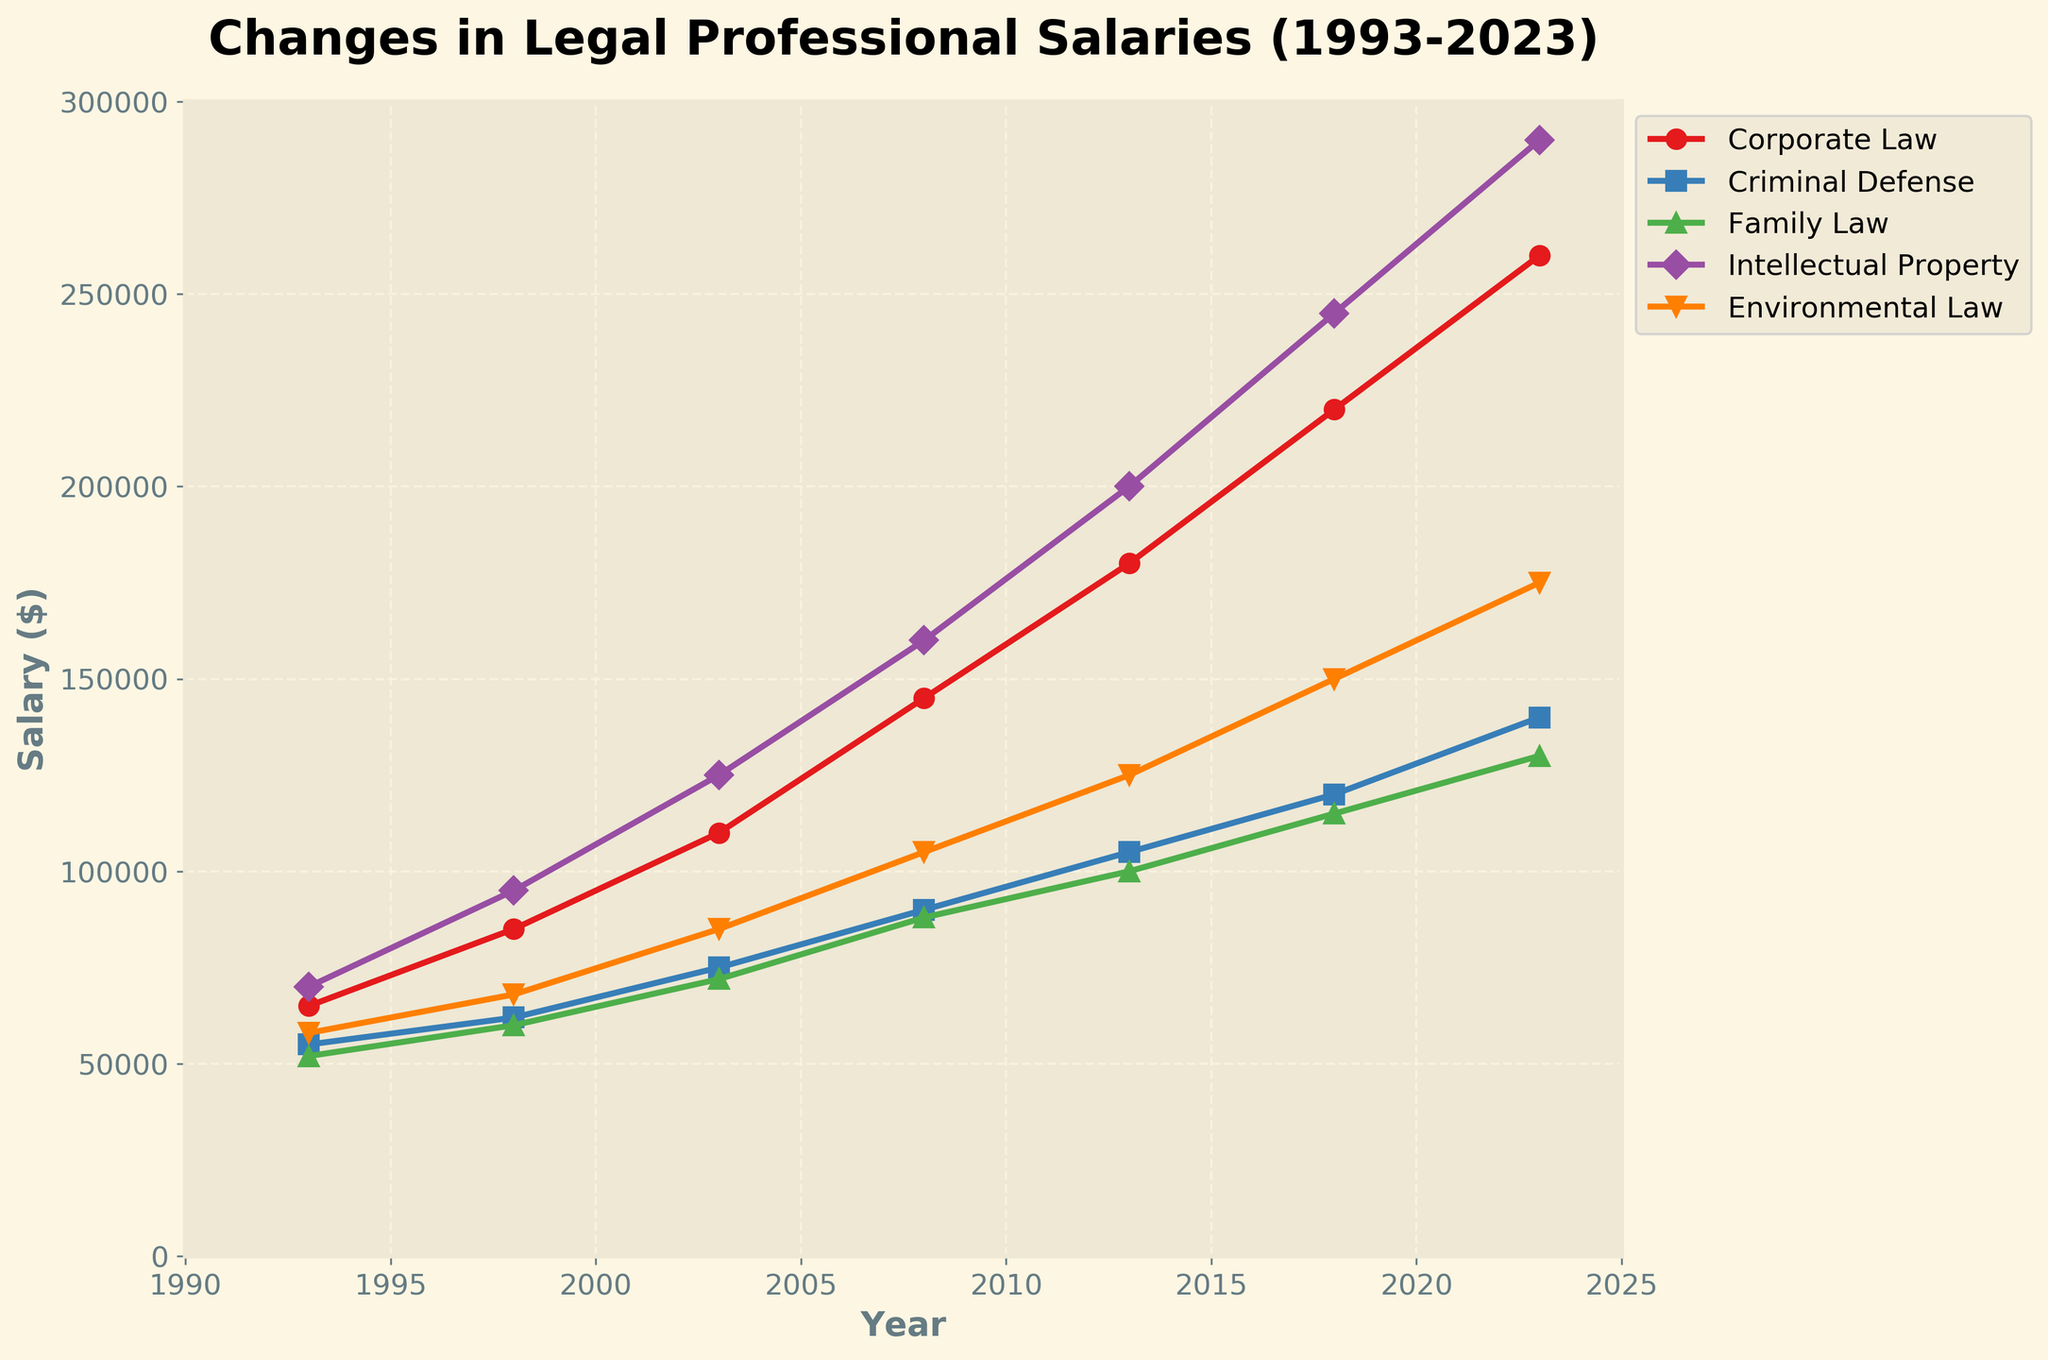Which practice area had the highest salary increase from 1993 to 2023? To determine the highest salary increase, we note the starting and ending salaries for each practice area: Corporate Law ($65,000 to $260,000), Criminal Defense ($55,000 to $140,000), Family Law ($52,000 to $130,000), Intellectual Property ($70,000 to $290,000), and Environmental Law ($58,000 to $175,000). The salary increase for Corporate Law is $195,000, for Criminal Defense is $85,000, for Family Law is $78,000, for Intellectual Property is $220,000, and for Environmental Law is $117,000. Thus, Intellectual Property had the highest increase.
Answer: Intellectual Property What year did Criminal Defense salaries surpass $100,000? To answer this, observe the salary values for Criminal Defense over time. In 1998, the salary was $62,000; in 2003, it was $75,000; in 2008, it was $90,000; in 2013, it surpassed $100,000 with a salary of $105,000.
Answer: 2013 Which practice area showed the smallest relative change in salary over the 30 years? To determine the smallest relative change, we calculate the relative increase (percentage increase) for each practice area. Corporate Law increased from $65,000 to $260,000 (300%), Criminal Defense from $55,000 to $140,000 (154.55%), Family Law from $52,000 to $130,000 (150%), Intellectual Property from $70,000 to $290,000 (314.29%), and Environmental Law from $58,000 to $175,000 (201.72%). Therefore, Family Law showed the smallest relative change.
Answer: Family Law Compare the salary of Corporate Law and Environmental Law in 2018 and indicate which is higher and by how much. In 2018, the salary for Corporate Law is $220,000 and for Environmental Law is $150,000. To find the difference, subtract the salary of Environmental Law from Corporate Law: $220,000 - $150,000 = $70,000. Hence, Corporate Law salaries were higher by $70,000.
Answer: Corporate Law by $70,000 In which period (five-year spans) did Intellectual Property see the most significant rise in salary? Observing the salary increments for each five-year span: 1993-1998 ($70,000 to $95,000; $25,000 increase), 1998-2003 ($95,000 to $125,000; $30,000 increase), 2003-2008 ($125,000 to $160,000; $35,000 increase), 2008-2013 ($160,000 to $200,000; $40,000 increase), 2013-2018 ($200,000 to $245,000; $45,000 increase), 2018-2023 ($245,000 to $290,000; $45,000 increase). The most significant rise was during the periods 2013-2018 and 2018-2023, both with an increase of $45,000.
Answer: 2013-2018 and 2018-2023 What are the colors and shapes of the markers representing Corporate Law and Family Law? According to the visual attributes in the chart, Corporate Law is represented by red circles, and Family Law is represented by green triangles.
Answer: Red circles for Corporate Law, Green triangles for Family Law Which practice area had the smallest salary in 2023, and what was the amount? By looking at the salaries in 2023 across all practice areas: Corporate Law ($260,000), Criminal Defense ($140,000), Family Law ($130,000), Intellectual Property ($290,000), and Environmental Law ($175,000), the smallest salary is found in Family Law, at $130,000.
Answer: Family Law, $130,000 